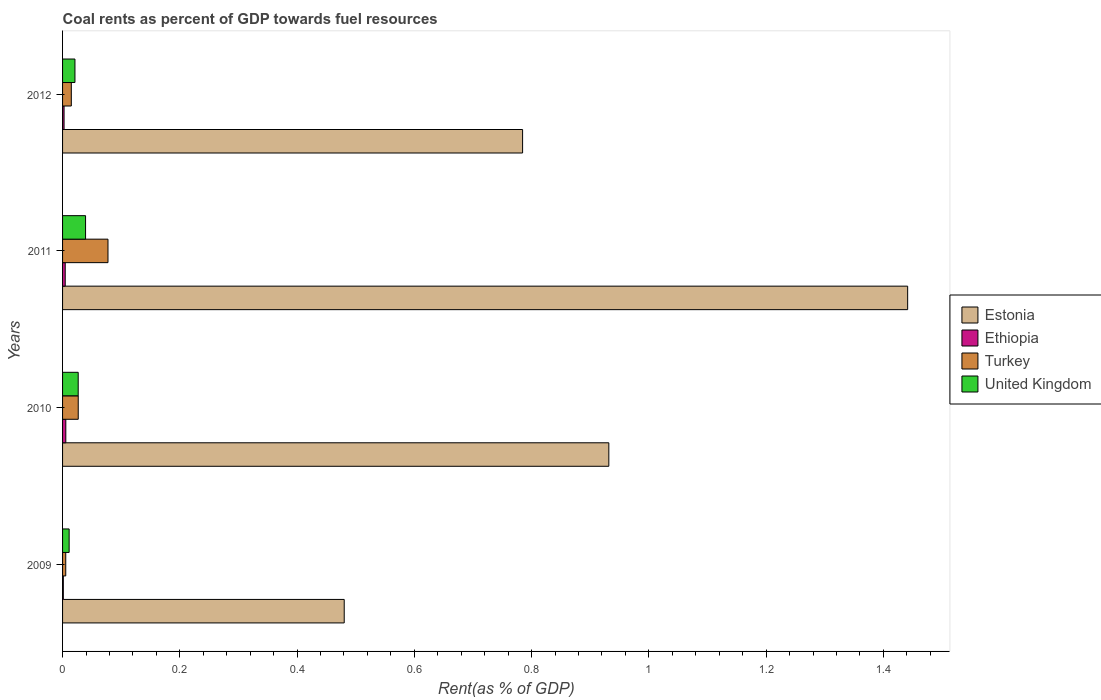How many different coloured bars are there?
Ensure brevity in your answer.  4. How many groups of bars are there?
Your answer should be compact. 4. Are the number of bars on each tick of the Y-axis equal?
Give a very brief answer. Yes. How many bars are there on the 1st tick from the bottom?
Keep it short and to the point. 4. In how many cases, is the number of bars for a given year not equal to the number of legend labels?
Give a very brief answer. 0. What is the coal rent in Ethiopia in 2009?
Keep it short and to the point. 0. Across all years, what is the maximum coal rent in Ethiopia?
Keep it short and to the point. 0.01. Across all years, what is the minimum coal rent in Ethiopia?
Your response must be concise. 0. In which year was the coal rent in Ethiopia maximum?
Offer a very short reply. 2010. What is the total coal rent in Ethiopia in the graph?
Offer a very short reply. 0.01. What is the difference between the coal rent in Turkey in 2009 and that in 2012?
Make the answer very short. -0.01. What is the difference between the coal rent in Turkey in 2011 and the coal rent in United Kingdom in 2012?
Give a very brief answer. 0.06. What is the average coal rent in United Kingdom per year?
Ensure brevity in your answer.  0.02. In the year 2012, what is the difference between the coal rent in Estonia and coal rent in Ethiopia?
Keep it short and to the point. 0.78. What is the ratio of the coal rent in Turkey in 2009 to that in 2011?
Keep it short and to the point. 0.07. What is the difference between the highest and the second highest coal rent in Estonia?
Ensure brevity in your answer.  0.51. What is the difference between the highest and the lowest coal rent in Turkey?
Give a very brief answer. 0.07. In how many years, is the coal rent in Turkey greater than the average coal rent in Turkey taken over all years?
Provide a short and direct response. 1. What does the 3rd bar from the top in 2009 represents?
Provide a succinct answer. Ethiopia. What does the 2nd bar from the bottom in 2011 represents?
Offer a terse response. Ethiopia. How many bars are there?
Provide a succinct answer. 16. Are all the bars in the graph horizontal?
Provide a short and direct response. Yes. How many years are there in the graph?
Make the answer very short. 4. Are the values on the major ticks of X-axis written in scientific E-notation?
Provide a succinct answer. No. Does the graph contain any zero values?
Provide a succinct answer. No. Where does the legend appear in the graph?
Make the answer very short. Center right. How many legend labels are there?
Keep it short and to the point. 4. How are the legend labels stacked?
Ensure brevity in your answer.  Vertical. What is the title of the graph?
Provide a short and direct response. Coal rents as percent of GDP towards fuel resources. What is the label or title of the X-axis?
Ensure brevity in your answer.  Rent(as % of GDP). What is the label or title of the Y-axis?
Offer a terse response. Years. What is the Rent(as % of GDP) in Estonia in 2009?
Your answer should be compact. 0.48. What is the Rent(as % of GDP) in Ethiopia in 2009?
Your response must be concise. 0. What is the Rent(as % of GDP) in Turkey in 2009?
Make the answer very short. 0.01. What is the Rent(as % of GDP) of United Kingdom in 2009?
Offer a terse response. 0.01. What is the Rent(as % of GDP) in Estonia in 2010?
Ensure brevity in your answer.  0.93. What is the Rent(as % of GDP) in Ethiopia in 2010?
Keep it short and to the point. 0.01. What is the Rent(as % of GDP) in Turkey in 2010?
Provide a succinct answer. 0.03. What is the Rent(as % of GDP) of United Kingdom in 2010?
Your answer should be compact. 0.03. What is the Rent(as % of GDP) in Estonia in 2011?
Your answer should be very brief. 1.44. What is the Rent(as % of GDP) of Ethiopia in 2011?
Your response must be concise. 0. What is the Rent(as % of GDP) of Turkey in 2011?
Provide a succinct answer. 0.08. What is the Rent(as % of GDP) in United Kingdom in 2011?
Keep it short and to the point. 0.04. What is the Rent(as % of GDP) in Estonia in 2012?
Provide a short and direct response. 0.78. What is the Rent(as % of GDP) in Ethiopia in 2012?
Give a very brief answer. 0. What is the Rent(as % of GDP) of Turkey in 2012?
Your response must be concise. 0.01. What is the Rent(as % of GDP) in United Kingdom in 2012?
Keep it short and to the point. 0.02. Across all years, what is the maximum Rent(as % of GDP) of Estonia?
Give a very brief answer. 1.44. Across all years, what is the maximum Rent(as % of GDP) in Ethiopia?
Your response must be concise. 0.01. Across all years, what is the maximum Rent(as % of GDP) of Turkey?
Ensure brevity in your answer.  0.08. Across all years, what is the maximum Rent(as % of GDP) of United Kingdom?
Provide a short and direct response. 0.04. Across all years, what is the minimum Rent(as % of GDP) in Estonia?
Keep it short and to the point. 0.48. Across all years, what is the minimum Rent(as % of GDP) in Ethiopia?
Ensure brevity in your answer.  0. Across all years, what is the minimum Rent(as % of GDP) in Turkey?
Offer a terse response. 0.01. Across all years, what is the minimum Rent(as % of GDP) of United Kingdom?
Ensure brevity in your answer.  0.01. What is the total Rent(as % of GDP) in Estonia in the graph?
Your response must be concise. 3.64. What is the total Rent(as % of GDP) of Ethiopia in the graph?
Offer a very short reply. 0.01. What is the total Rent(as % of GDP) of Turkey in the graph?
Your answer should be compact. 0.12. What is the total Rent(as % of GDP) in United Kingdom in the graph?
Your answer should be very brief. 0.1. What is the difference between the Rent(as % of GDP) of Estonia in 2009 and that in 2010?
Keep it short and to the point. -0.45. What is the difference between the Rent(as % of GDP) in Ethiopia in 2009 and that in 2010?
Offer a terse response. -0. What is the difference between the Rent(as % of GDP) of Turkey in 2009 and that in 2010?
Your answer should be compact. -0.02. What is the difference between the Rent(as % of GDP) of United Kingdom in 2009 and that in 2010?
Give a very brief answer. -0.02. What is the difference between the Rent(as % of GDP) of Estonia in 2009 and that in 2011?
Ensure brevity in your answer.  -0.96. What is the difference between the Rent(as % of GDP) of Ethiopia in 2009 and that in 2011?
Offer a terse response. -0. What is the difference between the Rent(as % of GDP) of Turkey in 2009 and that in 2011?
Your answer should be compact. -0.07. What is the difference between the Rent(as % of GDP) of United Kingdom in 2009 and that in 2011?
Provide a succinct answer. -0.03. What is the difference between the Rent(as % of GDP) of Estonia in 2009 and that in 2012?
Make the answer very short. -0.3. What is the difference between the Rent(as % of GDP) in Ethiopia in 2009 and that in 2012?
Provide a succinct answer. -0. What is the difference between the Rent(as % of GDP) in Turkey in 2009 and that in 2012?
Provide a succinct answer. -0.01. What is the difference between the Rent(as % of GDP) in United Kingdom in 2009 and that in 2012?
Your answer should be compact. -0.01. What is the difference between the Rent(as % of GDP) in Estonia in 2010 and that in 2011?
Offer a terse response. -0.51. What is the difference between the Rent(as % of GDP) in Ethiopia in 2010 and that in 2011?
Ensure brevity in your answer.  0. What is the difference between the Rent(as % of GDP) in Turkey in 2010 and that in 2011?
Keep it short and to the point. -0.05. What is the difference between the Rent(as % of GDP) in United Kingdom in 2010 and that in 2011?
Offer a terse response. -0.01. What is the difference between the Rent(as % of GDP) of Estonia in 2010 and that in 2012?
Give a very brief answer. 0.15. What is the difference between the Rent(as % of GDP) of Ethiopia in 2010 and that in 2012?
Your answer should be very brief. 0. What is the difference between the Rent(as % of GDP) of Turkey in 2010 and that in 2012?
Keep it short and to the point. 0.01. What is the difference between the Rent(as % of GDP) of United Kingdom in 2010 and that in 2012?
Offer a terse response. 0.01. What is the difference between the Rent(as % of GDP) of Estonia in 2011 and that in 2012?
Ensure brevity in your answer.  0.66. What is the difference between the Rent(as % of GDP) of Ethiopia in 2011 and that in 2012?
Ensure brevity in your answer.  0. What is the difference between the Rent(as % of GDP) in Turkey in 2011 and that in 2012?
Provide a short and direct response. 0.06. What is the difference between the Rent(as % of GDP) of United Kingdom in 2011 and that in 2012?
Ensure brevity in your answer.  0.02. What is the difference between the Rent(as % of GDP) of Estonia in 2009 and the Rent(as % of GDP) of Ethiopia in 2010?
Your answer should be compact. 0.47. What is the difference between the Rent(as % of GDP) in Estonia in 2009 and the Rent(as % of GDP) in Turkey in 2010?
Your response must be concise. 0.45. What is the difference between the Rent(as % of GDP) in Estonia in 2009 and the Rent(as % of GDP) in United Kingdom in 2010?
Ensure brevity in your answer.  0.45. What is the difference between the Rent(as % of GDP) in Ethiopia in 2009 and the Rent(as % of GDP) in Turkey in 2010?
Make the answer very short. -0.03. What is the difference between the Rent(as % of GDP) in Ethiopia in 2009 and the Rent(as % of GDP) in United Kingdom in 2010?
Give a very brief answer. -0.03. What is the difference between the Rent(as % of GDP) in Turkey in 2009 and the Rent(as % of GDP) in United Kingdom in 2010?
Offer a very short reply. -0.02. What is the difference between the Rent(as % of GDP) of Estonia in 2009 and the Rent(as % of GDP) of Ethiopia in 2011?
Your answer should be very brief. 0.48. What is the difference between the Rent(as % of GDP) in Estonia in 2009 and the Rent(as % of GDP) in Turkey in 2011?
Your answer should be compact. 0.4. What is the difference between the Rent(as % of GDP) in Estonia in 2009 and the Rent(as % of GDP) in United Kingdom in 2011?
Your answer should be very brief. 0.44. What is the difference between the Rent(as % of GDP) of Ethiopia in 2009 and the Rent(as % of GDP) of Turkey in 2011?
Offer a very short reply. -0.08. What is the difference between the Rent(as % of GDP) in Ethiopia in 2009 and the Rent(as % of GDP) in United Kingdom in 2011?
Provide a succinct answer. -0.04. What is the difference between the Rent(as % of GDP) in Turkey in 2009 and the Rent(as % of GDP) in United Kingdom in 2011?
Offer a very short reply. -0.03. What is the difference between the Rent(as % of GDP) of Estonia in 2009 and the Rent(as % of GDP) of Ethiopia in 2012?
Offer a terse response. 0.48. What is the difference between the Rent(as % of GDP) of Estonia in 2009 and the Rent(as % of GDP) of Turkey in 2012?
Your answer should be very brief. 0.47. What is the difference between the Rent(as % of GDP) of Estonia in 2009 and the Rent(as % of GDP) of United Kingdom in 2012?
Offer a very short reply. 0.46. What is the difference between the Rent(as % of GDP) of Ethiopia in 2009 and the Rent(as % of GDP) of Turkey in 2012?
Offer a terse response. -0.01. What is the difference between the Rent(as % of GDP) of Ethiopia in 2009 and the Rent(as % of GDP) of United Kingdom in 2012?
Your response must be concise. -0.02. What is the difference between the Rent(as % of GDP) of Turkey in 2009 and the Rent(as % of GDP) of United Kingdom in 2012?
Offer a very short reply. -0.02. What is the difference between the Rent(as % of GDP) in Estonia in 2010 and the Rent(as % of GDP) in Ethiopia in 2011?
Your answer should be very brief. 0.93. What is the difference between the Rent(as % of GDP) of Estonia in 2010 and the Rent(as % of GDP) of Turkey in 2011?
Keep it short and to the point. 0.85. What is the difference between the Rent(as % of GDP) of Estonia in 2010 and the Rent(as % of GDP) of United Kingdom in 2011?
Your answer should be very brief. 0.89. What is the difference between the Rent(as % of GDP) in Ethiopia in 2010 and the Rent(as % of GDP) in Turkey in 2011?
Give a very brief answer. -0.07. What is the difference between the Rent(as % of GDP) of Ethiopia in 2010 and the Rent(as % of GDP) of United Kingdom in 2011?
Offer a very short reply. -0.03. What is the difference between the Rent(as % of GDP) in Turkey in 2010 and the Rent(as % of GDP) in United Kingdom in 2011?
Offer a very short reply. -0.01. What is the difference between the Rent(as % of GDP) of Estonia in 2010 and the Rent(as % of GDP) of Ethiopia in 2012?
Ensure brevity in your answer.  0.93. What is the difference between the Rent(as % of GDP) of Estonia in 2010 and the Rent(as % of GDP) of Turkey in 2012?
Your answer should be very brief. 0.92. What is the difference between the Rent(as % of GDP) in Estonia in 2010 and the Rent(as % of GDP) in United Kingdom in 2012?
Keep it short and to the point. 0.91. What is the difference between the Rent(as % of GDP) in Ethiopia in 2010 and the Rent(as % of GDP) in Turkey in 2012?
Make the answer very short. -0.01. What is the difference between the Rent(as % of GDP) in Ethiopia in 2010 and the Rent(as % of GDP) in United Kingdom in 2012?
Make the answer very short. -0.02. What is the difference between the Rent(as % of GDP) of Turkey in 2010 and the Rent(as % of GDP) of United Kingdom in 2012?
Your answer should be compact. 0.01. What is the difference between the Rent(as % of GDP) in Estonia in 2011 and the Rent(as % of GDP) in Ethiopia in 2012?
Offer a very short reply. 1.44. What is the difference between the Rent(as % of GDP) of Estonia in 2011 and the Rent(as % of GDP) of Turkey in 2012?
Your answer should be very brief. 1.43. What is the difference between the Rent(as % of GDP) in Estonia in 2011 and the Rent(as % of GDP) in United Kingdom in 2012?
Provide a short and direct response. 1.42. What is the difference between the Rent(as % of GDP) of Ethiopia in 2011 and the Rent(as % of GDP) of Turkey in 2012?
Offer a terse response. -0.01. What is the difference between the Rent(as % of GDP) in Ethiopia in 2011 and the Rent(as % of GDP) in United Kingdom in 2012?
Provide a short and direct response. -0.02. What is the difference between the Rent(as % of GDP) of Turkey in 2011 and the Rent(as % of GDP) of United Kingdom in 2012?
Provide a succinct answer. 0.06. What is the average Rent(as % of GDP) in Estonia per year?
Keep it short and to the point. 0.91. What is the average Rent(as % of GDP) of Ethiopia per year?
Keep it short and to the point. 0. What is the average Rent(as % of GDP) of Turkey per year?
Offer a terse response. 0.03. What is the average Rent(as % of GDP) in United Kingdom per year?
Offer a very short reply. 0.02. In the year 2009, what is the difference between the Rent(as % of GDP) in Estonia and Rent(as % of GDP) in Ethiopia?
Keep it short and to the point. 0.48. In the year 2009, what is the difference between the Rent(as % of GDP) in Estonia and Rent(as % of GDP) in Turkey?
Your answer should be compact. 0.47. In the year 2009, what is the difference between the Rent(as % of GDP) of Estonia and Rent(as % of GDP) of United Kingdom?
Your answer should be compact. 0.47. In the year 2009, what is the difference between the Rent(as % of GDP) of Ethiopia and Rent(as % of GDP) of Turkey?
Your answer should be compact. -0. In the year 2009, what is the difference between the Rent(as % of GDP) of Ethiopia and Rent(as % of GDP) of United Kingdom?
Offer a terse response. -0.01. In the year 2009, what is the difference between the Rent(as % of GDP) of Turkey and Rent(as % of GDP) of United Kingdom?
Your answer should be compact. -0.01. In the year 2010, what is the difference between the Rent(as % of GDP) in Estonia and Rent(as % of GDP) in Ethiopia?
Offer a terse response. 0.93. In the year 2010, what is the difference between the Rent(as % of GDP) in Estonia and Rent(as % of GDP) in Turkey?
Give a very brief answer. 0.91. In the year 2010, what is the difference between the Rent(as % of GDP) in Estonia and Rent(as % of GDP) in United Kingdom?
Offer a terse response. 0.91. In the year 2010, what is the difference between the Rent(as % of GDP) of Ethiopia and Rent(as % of GDP) of Turkey?
Your answer should be compact. -0.02. In the year 2010, what is the difference between the Rent(as % of GDP) in Ethiopia and Rent(as % of GDP) in United Kingdom?
Provide a succinct answer. -0.02. In the year 2011, what is the difference between the Rent(as % of GDP) in Estonia and Rent(as % of GDP) in Ethiopia?
Ensure brevity in your answer.  1.44. In the year 2011, what is the difference between the Rent(as % of GDP) of Estonia and Rent(as % of GDP) of Turkey?
Ensure brevity in your answer.  1.36. In the year 2011, what is the difference between the Rent(as % of GDP) in Estonia and Rent(as % of GDP) in United Kingdom?
Your answer should be compact. 1.4. In the year 2011, what is the difference between the Rent(as % of GDP) of Ethiopia and Rent(as % of GDP) of Turkey?
Offer a terse response. -0.07. In the year 2011, what is the difference between the Rent(as % of GDP) in Ethiopia and Rent(as % of GDP) in United Kingdom?
Your response must be concise. -0.03. In the year 2011, what is the difference between the Rent(as % of GDP) in Turkey and Rent(as % of GDP) in United Kingdom?
Offer a terse response. 0.04. In the year 2012, what is the difference between the Rent(as % of GDP) in Estonia and Rent(as % of GDP) in Ethiopia?
Offer a terse response. 0.78. In the year 2012, what is the difference between the Rent(as % of GDP) in Estonia and Rent(as % of GDP) in Turkey?
Give a very brief answer. 0.77. In the year 2012, what is the difference between the Rent(as % of GDP) in Estonia and Rent(as % of GDP) in United Kingdom?
Provide a succinct answer. 0.76. In the year 2012, what is the difference between the Rent(as % of GDP) in Ethiopia and Rent(as % of GDP) in Turkey?
Your answer should be very brief. -0.01. In the year 2012, what is the difference between the Rent(as % of GDP) of Ethiopia and Rent(as % of GDP) of United Kingdom?
Offer a very short reply. -0.02. In the year 2012, what is the difference between the Rent(as % of GDP) in Turkey and Rent(as % of GDP) in United Kingdom?
Offer a very short reply. -0.01. What is the ratio of the Rent(as % of GDP) in Estonia in 2009 to that in 2010?
Offer a terse response. 0.52. What is the ratio of the Rent(as % of GDP) in Ethiopia in 2009 to that in 2010?
Keep it short and to the point. 0.24. What is the ratio of the Rent(as % of GDP) in Turkey in 2009 to that in 2010?
Offer a very short reply. 0.2. What is the ratio of the Rent(as % of GDP) in United Kingdom in 2009 to that in 2010?
Your answer should be compact. 0.42. What is the ratio of the Rent(as % of GDP) in Ethiopia in 2009 to that in 2011?
Offer a very short reply. 0.29. What is the ratio of the Rent(as % of GDP) of Turkey in 2009 to that in 2011?
Your answer should be very brief. 0.07. What is the ratio of the Rent(as % of GDP) in United Kingdom in 2009 to that in 2011?
Give a very brief answer. 0.29. What is the ratio of the Rent(as % of GDP) in Estonia in 2009 to that in 2012?
Offer a terse response. 0.61. What is the ratio of the Rent(as % of GDP) of Ethiopia in 2009 to that in 2012?
Offer a terse response. 0.51. What is the ratio of the Rent(as % of GDP) in Turkey in 2009 to that in 2012?
Your answer should be compact. 0.36. What is the ratio of the Rent(as % of GDP) in United Kingdom in 2009 to that in 2012?
Offer a terse response. 0.53. What is the ratio of the Rent(as % of GDP) of Estonia in 2010 to that in 2011?
Ensure brevity in your answer.  0.65. What is the ratio of the Rent(as % of GDP) of Ethiopia in 2010 to that in 2011?
Your response must be concise. 1.23. What is the ratio of the Rent(as % of GDP) in Turkey in 2010 to that in 2011?
Provide a succinct answer. 0.34. What is the ratio of the Rent(as % of GDP) in United Kingdom in 2010 to that in 2011?
Make the answer very short. 0.68. What is the ratio of the Rent(as % of GDP) in Estonia in 2010 to that in 2012?
Offer a terse response. 1.19. What is the ratio of the Rent(as % of GDP) in Ethiopia in 2010 to that in 2012?
Your answer should be very brief. 2.16. What is the ratio of the Rent(as % of GDP) of Turkey in 2010 to that in 2012?
Make the answer very short. 1.79. What is the ratio of the Rent(as % of GDP) in United Kingdom in 2010 to that in 2012?
Your answer should be very brief. 1.26. What is the ratio of the Rent(as % of GDP) of Estonia in 2011 to that in 2012?
Ensure brevity in your answer.  1.84. What is the ratio of the Rent(as % of GDP) of Ethiopia in 2011 to that in 2012?
Your response must be concise. 1.76. What is the ratio of the Rent(as % of GDP) of Turkey in 2011 to that in 2012?
Offer a very short reply. 5.2. What is the ratio of the Rent(as % of GDP) of United Kingdom in 2011 to that in 2012?
Your response must be concise. 1.86. What is the difference between the highest and the second highest Rent(as % of GDP) of Estonia?
Ensure brevity in your answer.  0.51. What is the difference between the highest and the second highest Rent(as % of GDP) of Turkey?
Your response must be concise. 0.05. What is the difference between the highest and the second highest Rent(as % of GDP) of United Kingdom?
Offer a very short reply. 0.01. What is the difference between the highest and the lowest Rent(as % of GDP) in Estonia?
Provide a short and direct response. 0.96. What is the difference between the highest and the lowest Rent(as % of GDP) of Ethiopia?
Give a very brief answer. 0. What is the difference between the highest and the lowest Rent(as % of GDP) of Turkey?
Offer a terse response. 0.07. What is the difference between the highest and the lowest Rent(as % of GDP) of United Kingdom?
Keep it short and to the point. 0.03. 